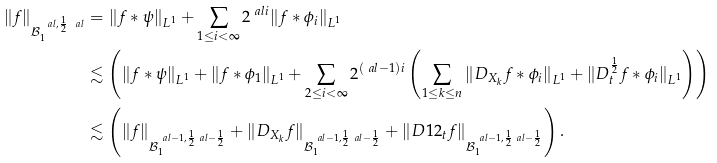<formula> <loc_0><loc_0><loc_500><loc_500>\| f \| _ { { \mathcal { B } } ^ { \ a l , \frac { 1 } { 2 } \ a l } _ { 1 } } & = \| f * \psi \| _ { L ^ { 1 } } + \sum _ { 1 \leq i < \infty } 2 ^ { \ a l i } \| f * \phi _ { i } \| _ { L ^ { 1 } } \\ & \lesssim \left ( \| f * \psi \| _ { L ^ { 1 } } + \| f * \phi _ { 1 } \| _ { L ^ { 1 } } + \sum _ { 2 \leq i < \infty } 2 ^ { ( \ a l - 1 ) i } \left ( \sum _ { 1 \leq k \leq n } \| D _ { X _ { k } } f * \phi _ { i } \| _ { L ^ { 1 } } + \| D ^ { \frac { 1 } { 2 } } _ { t } f * \phi _ { i } \| _ { L ^ { 1 } } \right ) \right ) \\ & \lesssim \left ( \| f \| _ { { \mathcal { B } } ^ { \ a l - 1 , \frac { 1 } { 2 } \ a l - \frac { 1 } { 2 } } _ { 1 } } + \| D _ { X _ { k } } f \| _ { { \mathcal { B } } ^ { \ a l - 1 , \frac { 1 } { 2 } \ a l - \frac { 1 } { 2 } } _ { 1 } } + \| D ^ { } { 1 } 2 _ { t } f \| _ { { \mathcal { B } } ^ { \ a l - 1 , \frac { 1 } { 2 } \ a l - \frac { 1 } { 2 } } _ { 1 } } \right ) .</formula> 